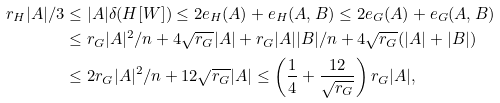<formula> <loc_0><loc_0><loc_500><loc_500>r _ { H } | A | / 3 & \leq | A | \delta ( H [ W ] ) \leq 2 e _ { H } ( A ) + e _ { H } ( A , B ) \leq 2 e _ { G } ( A ) + e _ { G } ( A , B ) \\ & \leq r _ { G } | A | ^ { 2 } / n + 4 \sqrt { r _ { G } } | A | + r _ { G } | A | | B | / n + 4 \sqrt { r _ { G } } ( | A | + | B | ) \\ & \leq 2 r _ { G } | A | ^ { 2 } / n + 1 2 \sqrt { r _ { G } } | A | \leq \left ( \frac { 1 } { 4 } + \frac { 1 2 } { \sqrt { r _ { G } } } \right ) r _ { G } | A | ,</formula> 